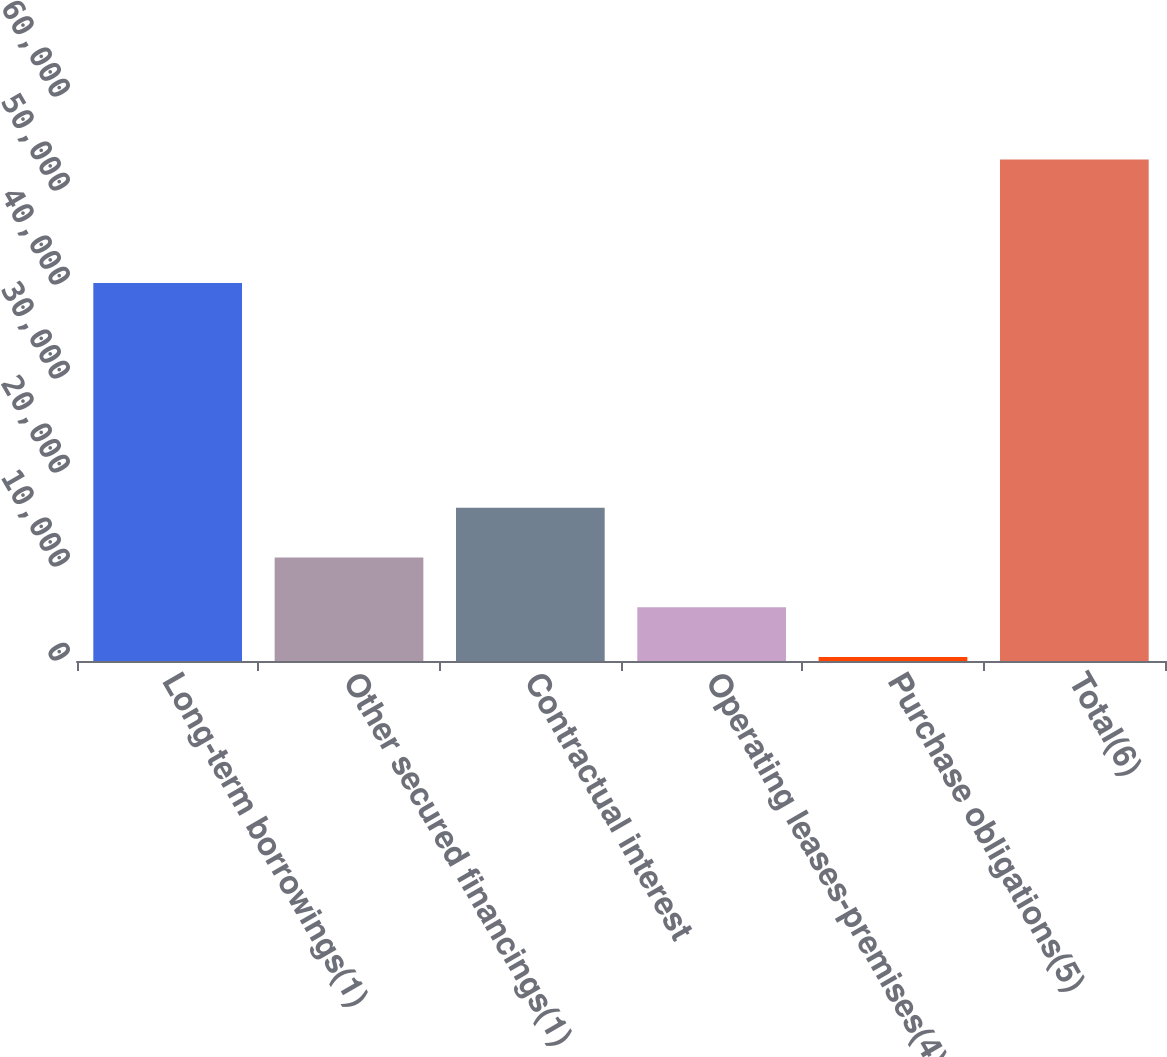Convert chart to OTSL. <chart><loc_0><loc_0><loc_500><loc_500><bar_chart><fcel>Long-term borrowings(1)<fcel>Other secured financings(1)<fcel>Contractual interest<fcel>Operating leases-premises(4)<fcel>Purchase obligations(5)<fcel>Total(6)<nl><fcel>40203<fcel>11022.2<fcel>16314.3<fcel>5730.1<fcel>438<fcel>53359<nl></chart> 